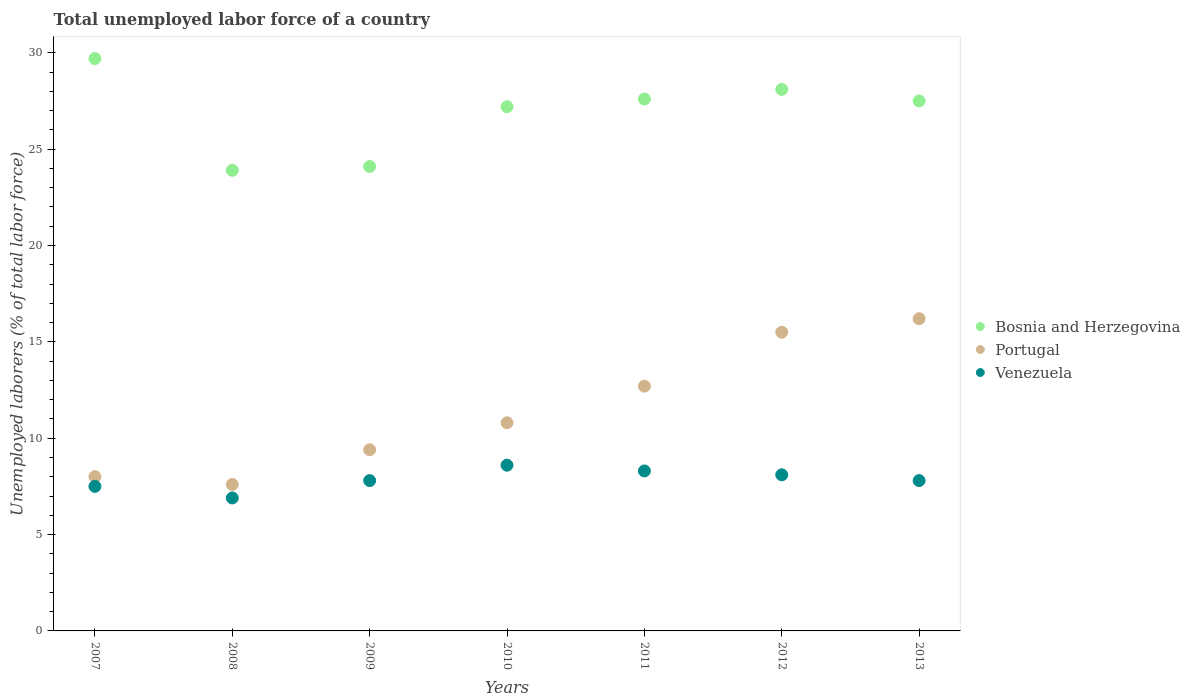Is the number of dotlines equal to the number of legend labels?
Keep it short and to the point. Yes. Across all years, what is the maximum total unemployed labor force in Bosnia and Herzegovina?
Your answer should be very brief. 29.7. Across all years, what is the minimum total unemployed labor force in Portugal?
Provide a short and direct response. 7.6. What is the total total unemployed labor force in Portugal in the graph?
Give a very brief answer. 80.2. What is the difference between the total unemployed labor force in Venezuela in 2007 and that in 2010?
Your answer should be compact. -1.1. What is the difference between the total unemployed labor force in Portugal in 2009 and the total unemployed labor force in Bosnia and Herzegovina in 2010?
Make the answer very short. -17.8. What is the average total unemployed labor force in Bosnia and Herzegovina per year?
Provide a short and direct response. 26.87. In the year 2011, what is the difference between the total unemployed labor force in Venezuela and total unemployed labor force in Portugal?
Ensure brevity in your answer.  -4.4. In how many years, is the total unemployed labor force in Venezuela greater than 6 %?
Make the answer very short. 7. What is the ratio of the total unemployed labor force in Bosnia and Herzegovina in 2007 to that in 2008?
Provide a succinct answer. 1.24. Is the total unemployed labor force in Venezuela in 2010 less than that in 2011?
Ensure brevity in your answer.  No. Is the difference between the total unemployed labor force in Venezuela in 2007 and 2011 greater than the difference between the total unemployed labor force in Portugal in 2007 and 2011?
Provide a succinct answer. Yes. What is the difference between the highest and the second highest total unemployed labor force in Bosnia and Herzegovina?
Provide a short and direct response. 1.6. What is the difference between the highest and the lowest total unemployed labor force in Venezuela?
Give a very brief answer. 1.7. Is the sum of the total unemployed labor force in Portugal in 2007 and 2009 greater than the maximum total unemployed labor force in Bosnia and Herzegovina across all years?
Give a very brief answer. No. Is the total unemployed labor force in Portugal strictly less than the total unemployed labor force in Venezuela over the years?
Make the answer very short. No. How many dotlines are there?
Keep it short and to the point. 3. How many years are there in the graph?
Your answer should be compact. 7. Are the values on the major ticks of Y-axis written in scientific E-notation?
Provide a succinct answer. No. Does the graph contain any zero values?
Keep it short and to the point. No. Does the graph contain grids?
Keep it short and to the point. No. How many legend labels are there?
Your answer should be very brief. 3. How are the legend labels stacked?
Ensure brevity in your answer.  Vertical. What is the title of the graph?
Keep it short and to the point. Total unemployed labor force of a country. What is the label or title of the Y-axis?
Ensure brevity in your answer.  Unemployed laborers (% of total labor force). What is the Unemployed laborers (% of total labor force) of Bosnia and Herzegovina in 2007?
Give a very brief answer. 29.7. What is the Unemployed laborers (% of total labor force) in Bosnia and Herzegovina in 2008?
Ensure brevity in your answer.  23.9. What is the Unemployed laborers (% of total labor force) of Portugal in 2008?
Your response must be concise. 7.6. What is the Unemployed laborers (% of total labor force) of Venezuela in 2008?
Make the answer very short. 6.9. What is the Unemployed laborers (% of total labor force) of Bosnia and Herzegovina in 2009?
Your answer should be very brief. 24.1. What is the Unemployed laborers (% of total labor force) of Portugal in 2009?
Offer a very short reply. 9.4. What is the Unemployed laborers (% of total labor force) of Venezuela in 2009?
Offer a terse response. 7.8. What is the Unemployed laborers (% of total labor force) in Bosnia and Herzegovina in 2010?
Ensure brevity in your answer.  27.2. What is the Unemployed laborers (% of total labor force) in Portugal in 2010?
Your answer should be compact. 10.8. What is the Unemployed laborers (% of total labor force) of Venezuela in 2010?
Your answer should be very brief. 8.6. What is the Unemployed laborers (% of total labor force) in Bosnia and Herzegovina in 2011?
Offer a very short reply. 27.6. What is the Unemployed laborers (% of total labor force) of Portugal in 2011?
Your answer should be compact. 12.7. What is the Unemployed laborers (% of total labor force) in Venezuela in 2011?
Ensure brevity in your answer.  8.3. What is the Unemployed laborers (% of total labor force) of Bosnia and Herzegovina in 2012?
Make the answer very short. 28.1. What is the Unemployed laborers (% of total labor force) in Portugal in 2012?
Provide a succinct answer. 15.5. What is the Unemployed laborers (% of total labor force) in Venezuela in 2012?
Provide a short and direct response. 8.1. What is the Unemployed laborers (% of total labor force) in Bosnia and Herzegovina in 2013?
Offer a terse response. 27.5. What is the Unemployed laborers (% of total labor force) of Portugal in 2013?
Offer a terse response. 16.2. What is the Unemployed laborers (% of total labor force) in Venezuela in 2013?
Offer a terse response. 7.8. Across all years, what is the maximum Unemployed laborers (% of total labor force) in Bosnia and Herzegovina?
Your answer should be compact. 29.7. Across all years, what is the maximum Unemployed laborers (% of total labor force) of Portugal?
Your answer should be very brief. 16.2. Across all years, what is the maximum Unemployed laborers (% of total labor force) in Venezuela?
Give a very brief answer. 8.6. Across all years, what is the minimum Unemployed laborers (% of total labor force) in Bosnia and Herzegovina?
Your answer should be compact. 23.9. Across all years, what is the minimum Unemployed laborers (% of total labor force) of Portugal?
Your answer should be compact. 7.6. Across all years, what is the minimum Unemployed laborers (% of total labor force) in Venezuela?
Your response must be concise. 6.9. What is the total Unemployed laborers (% of total labor force) of Bosnia and Herzegovina in the graph?
Keep it short and to the point. 188.1. What is the total Unemployed laborers (% of total labor force) in Portugal in the graph?
Give a very brief answer. 80.2. What is the difference between the Unemployed laborers (% of total labor force) in Portugal in 2007 and that in 2008?
Your response must be concise. 0.4. What is the difference between the Unemployed laborers (% of total labor force) of Venezuela in 2007 and that in 2008?
Your answer should be compact. 0.6. What is the difference between the Unemployed laborers (% of total labor force) in Bosnia and Herzegovina in 2007 and that in 2009?
Ensure brevity in your answer.  5.6. What is the difference between the Unemployed laborers (% of total labor force) in Venezuela in 2007 and that in 2009?
Keep it short and to the point. -0.3. What is the difference between the Unemployed laborers (% of total labor force) of Bosnia and Herzegovina in 2007 and that in 2010?
Offer a terse response. 2.5. What is the difference between the Unemployed laborers (% of total labor force) in Venezuela in 2007 and that in 2010?
Give a very brief answer. -1.1. What is the difference between the Unemployed laborers (% of total labor force) of Portugal in 2007 and that in 2011?
Keep it short and to the point. -4.7. What is the difference between the Unemployed laborers (% of total labor force) in Venezuela in 2007 and that in 2011?
Make the answer very short. -0.8. What is the difference between the Unemployed laborers (% of total labor force) of Bosnia and Herzegovina in 2007 and that in 2012?
Offer a very short reply. 1.6. What is the difference between the Unemployed laborers (% of total labor force) of Portugal in 2007 and that in 2012?
Your answer should be compact. -7.5. What is the difference between the Unemployed laborers (% of total labor force) in Bosnia and Herzegovina in 2007 and that in 2013?
Provide a succinct answer. 2.2. What is the difference between the Unemployed laborers (% of total labor force) of Bosnia and Herzegovina in 2008 and that in 2009?
Make the answer very short. -0.2. What is the difference between the Unemployed laborers (% of total labor force) of Venezuela in 2008 and that in 2009?
Provide a succinct answer. -0.9. What is the difference between the Unemployed laborers (% of total labor force) in Bosnia and Herzegovina in 2008 and that in 2010?
Your response must be concise. -3.3. What is the difference between the Unemployed laborers (% of total labor force) in Portugal in 2008 and that in 2010?
Give a very brief answer. -3.2. What is the difference between the Unemployed laborers (% of total labor force) in Venezuela in 2008 and that in 2010?
Offer a very short reply. -1.7. What is the difference between the Unemployed laborers (% of total labor force) in Bosnia and Herzegovina in 2008 and that in 2011?
Give a very brief answer. -3.7. What is the difference between the Unemployed laborers (% of total labor force) of Portugal in 2008 and that in 2011?
Provide a short and direct response. -5.1. What is the difference between the Unemployed laborers (% of total labor force) of Portugal in 2008 and that in 2012?
Provide a succinct answer. -7.9. What is the difference between the Unemployed laborers (% of total labor force) of Bosnia and Herzegovina in 2008 and that in 2013?
Make the answer very short. -3.6. What is the difference between the Unemployed laborers (% of total labor force) in Venezuela in 2008 and that in 2013?
Your answer should be very brief. -0.9. What is the difference between the Unemployed laborers (% of total labor force) in Venezuela in 2009 and that in 2010?
Keep it short and to the point. -0.8. What is the difference between the Unemployed laborers (% of total labor force) in Bosnia and Herzegovina in 2009 and that in 2011?
Keep it short and to the point. -3.5. What is the difference between the Unemployed laborers (% of total labor force) in Portugal in 2009 and that in 2011?
Your response must be concise. -3.3. What is the difference between the Unemployed laborers (% of total labor force) in Venezuela in 2009 and that in 2013?
Give a very brief answer. 0. What is the difference between the Unemployed laborers (% of total labor force) of Bosnia and Herzegovina in 2010 and that in 2011?
Your answer should be compact. -0.4. What is the difference between the Unemployed laborers (% of total labor force) in Bosnia and Herzegovina in 2010 and that in 2012?
Give a very brief answer. -0.9. What is the difference between the Unemployed laborers (% of total labor force) of Portugal in 2010 and that in 2012?
Your answer should be very brief. -4.7. What is the difference between the Unemployed laborers (% of total labor force) of Venezuela in 2010 and that in 2013?
Offer a very short reply. 0.8. What is the difference between the Unemployed laborers (% of total labor force) in Bosnia and Herzegovina in 2011 and that in 2013?
Give a very brief answer. 0.1. What is the difference between the Unemployed laborers (% of total labor force) of Portugal in 2011 and that in 2013?
Your answer should be compact. -3.5. What is the difference between the Unemployed laborers (% of total labor force) in Venezuela in 2011 and that in 2013?
Ensure brevity in your answer.  0.5. What is the difference between the Unemployed laborers (% of total labor force) in Portugal in 2012 and that in 2013?
Provide a short and direct response. -0.7. What is the difference between the Unemployed laborers (% of total labor force) of Venezuela in 2012 and that in 2013?
Make the answer very short. 0.3. What is the difference between the Unemployed laborers (% of total labor force) in Bosnia and Herzegovina in 2007 and the Unemployed laborers (% of total labor force) in Portugal in 2008?
Keep it short and to the point. 22.1. What is the difference between the Unemployed laborers (% of total labor force) of Bosnia and Herzegovina in 2007 and the Unemployed laborers (% of total labor force) of Venezuela in 2008?
Provide a short and direct response. 22.8. What is the difference between the Unemployed laborers (% of total labor force) in Portugal in 2007 and the Unemployed laborers (% of total labor force) in Venezuela in 2008?
Ensure brevity in your answer.  1.1. What is the difference between the Unemployed laborers (% of total labor force) of Bosnia and Herzegovina in 2007 and the Unemployed laborers (% of total labor force) of Portugal in 2009?
Your answer should be very brief. 20.3. What is the difference between the Unemployed laborers (% of total labor force) in Bosnia and Herzegovina in 2007 and the Unemployed laborers (% of total labor force) in Venezuela in 2009?
Keep it short and to the point. 21.9. What is the difference between the Unemployed laborers (% of total labor force) in Portugal in 2007 and the Unemployed laborers (% of total labor force) in Venezuela in 2009?
Keep it short and to the point. 0.2. What is the difference between the Unemployed laborers (% of total labor force) in Bosnia and Herzegovina in 2007 and the Unemployed laborers (% of total labor force) in Portugal in 2010?
Ensure brevity in your answer.  18.9. What is the difference between the Unemployed laborers (% of total labor force) in Bosnia and Herzegovina in 2007 and the Unemployed laborers (% of total labor force) in Venezuela in 2010?
Provide a succinct answer. 21.1. What is the difference between the Unemployed laborers (% of total labor force) in Portugal in 2007 and the Unemployed laborers (% of total labor force) in Venezuela in 2010?
Your answer should be compact. -0.6. What is the difference between the Unemployed laborers (% of total labor force) of Bosnia and Herzegovina in 2007 and the Unemployed laborers (% of total labor force) of Venezuela in 2011?
Keep it short and to the point. 21.4. What is the difference between the Unemployed laborers (% of total labor force) of Bosnia and Herzegovina in 2007 and the Unemployed laborers (% of total labor force) of Venezuela in 2012?
Your answer should be very brief. 21.6. What is the difference between the Unemployed laborers (% of total labor force) of Portugal in 2007 and the Unemployed laborers (% of total labor force) of Venezuela in 2012?
Offer a terse response. -0.1. What is the difference between the Unemployed laborers (% of total labor force) of Bosnia and Herzegovina in 2007 and the Unemployed laborers (% of total labor force) of Venezuela in 2013?
Your answer should be very brief. 21.9. What is the difference between the Unemployed laborers (% of total labor force) in Bosnia and Herzegovina in 2008 and the Unemployed laborers (% of total labor force) in Portugal in 2009?
Your answer should be compact. 14.5. What is the difference between the Unemployed laborers (% of total labor force) of Bosnia and Herzegovina in 2008 and the Unemployed laborers (% of total labor force) of Venezuela in 2009?
Your response must be concise. 16.1. What is the difference between the Unemployed laborers (% of total labor force) of Portugal in 2008 and the Unemployed laborers (% of total labor force) of Venezuela in 2009?
Keep it short and to the point. -0.2. What is the difference between the Unemployed laborers (% of total labor force) in Bosnia and Herzegovina in 2008 and the Unemployed laborers (% of total labor force) in Venezuela in 2011?
Make the answer very short. 15.6. What is the difference between the Unemployed laborers (% of total labor force) in Portugal in 2008 and the Unemployed laborers (% of total labor force) in Venezuela in 2011?
Your answer should be very brief. -0.7. What is the difference between the Unemployed laborers (% of total labor force) of Bosnia and Herzegovina in 2008 and the Unemployed laborers (% of total labor force) of Venezuela in 2012?
Your answer should be compact. 15.8. What is the difference between the Unemployed laborers (% of total labor force) in Portugal in 2008 and the Unemployed laborers (% of total labor force) in Venezuela in 2012?
Give a very brief answer. -0.5. What is the difference between the Unemployed laborers (% of total labor force) in Bosnia and Herzegovina in 2008 and the Unemployed laborers (% of total labor force) in Portugal in 2013?
Provide a short and direct response. 7.7. What is the difference between the Unemployed laborers (% of total labor force) of Bosnia and Herzegovina in 2009 and the Unemployed laborers (% of total labor force) of Portugal in 2010?
Provide a short and direct response. 13.3. What is the difference between the Unemployed laborers (% of total labor force) of Bosnia and Herzegovina in 2009 and the Unemployed laborers (% of total labor force) of Venezuela in 2010?
Give a very brief answer. 15.5. What is the difference between the Unemployed laborers (% of total labor force) in Bosnia and Herzegovina in 2009 and the Unemployed laborers (% of total labor force) in Portugal in 2011?
Ensure brevity in your answer.  11.4. What is the difference between the Unemployed laborers (% of total labor force) in Portugal in 2009 and the Unemployed laborers (% of total labor force) in Venezuela in 2011?
Your response must be concise. 1.1. What is the difference between the Unemployed laborers (% of total labor force) of Bosnia and Herzegovina in 2009 and the Unemployed laborers (% of total labor force) of Venezuela in 2012?
Give a very brief answer. 16. What is the difference between the Unemployed laborers (% of total labor force) of Bosnia and Herzegovina in 2009 and the Unemployed laborers (% of total labor force) of Portugal in 2013?
Your answer should be compact. 7.9. What is the difference between the Unemployed laborers (% of total labor force) in Bosnia and Herzegovina in 2009 and the Unemployed laborers (% of total labor force) in Venezuela in 2013?
Your answer should be compact. 16.3. What is the difference between the Unemployed laborers (% of total labor force) of Portugal in 2010 and the Unemployed laborers (% of total labor force) of Venezuela in 2012?
Your response must be concise. 2.7. What is the difference between the Unemployed laborers (% of total labor force) in Portugal in 2010 and the Unemployed laborers (% of total labor force) in Venezuela in 2013?
Provide a succinct answer. 3. What is the difference between the Unemployed laborers (% of total labor force) of Bosnia and Herzegovina in 2011 and the Unemployed laborers (% of total labor force) of Portugal in 2012?
Provide a succinct answer. 12.1. What is the difference between the Unemployed laborers (% of total labor force) of Bosnia and Herzegovina in 2011 and the Unemployed laborers (% of total labor force) of Venezuela in 2013?
Your answer should be very brief. 19.8. What is the difference between the Unemployed laborers (% of total labor force) of Portugal in 2011 and the Unemployed laborers (% of total labor force) of Venezuela in 2013?
Give a very brief answer. 4.9. What is the difference between the Unemployed laborers (% of total labor force) in Bosnia and Herzegovina in 2012 and the Unemployed laborers (% of total labor force) in Venezuela in 2013?
Your response must be concise. 20.3. What is the average Unemployed laborers (% of total labor force) of Bosnia and Herzegovina per year?
Ensure brevity in your answer.  26.87. What is the average Unemployed laborers (% of total labor force) of Portugal per year?
Give a very brief answer. 11.46. What is the average Unemployed laborers (% of total labor force) of Venezuela per year?
Give a very brief answer. 7.86. In the year 2007, what is the difference between the Unemployed laborers (% of total labor force) in Bosnia and Herzegovina and Unemployed laborers (% of total labor force) in Portugal?
Give a very brief answer. 21.7. In the year 2007, what is the difference between the Unemployed laborers (% of total labor force) in Bosnia and Herzegovina and Unemployed laborers (% of total labor force) in Venezuela?
Your response must be concise. 22.2. In the year 2007, what is the difference between the Unemployed laborers (% of total labor force) in Portugal and Unemployed laborers (% of total labor force) in Venezuela?
Give a very brief answer. 0.5. In the year 2008, what is the difference between the Unemployed laborers (% of total labor force) in Bosnia and Herzegovina and Unemployed laborers (% of total labor force) in Portugal?
Offer a terse response. 16.3. In the year 2008, what is the difference between the Unemployed laborers (% of total labor force) of Bosnia and Herzegovina and Unemployed laborers (% of total labor force) of Venezuela?
Offer a very short reply. 17. In the year 2008, what is the difference between the Unemployed laborers (% of total labor force) of Portugal and Unemployed laborers (% of total labor force) of Venezuela?
Give a very brief answer. 0.7. In the year 2009, what is the difference between the Unemployed laborers (% of total labor force) in Bosnia and Herzegovina and Unemployed laborers (% of total labor force) in Portugal?
Offer a very short reply. 14.7. In the year 2009, what is the difference between the Unemployed laborers (% of total labor force) of Bosnia and Herzegovina and Unemployed laborers (% of total labor force) of Venezuela?
Offer a terse response. 16.3. In the year 2010, what is the difference between the Unemployed laborers (% of total labor force) of Bosnia and Herzegovina and Unemployed laborers (% of total labor force) of Venezuela?
Your answer should be compact. 18.6. In the year 2010, what is the difference between the Unemployed laborers (% of total labor force) in Portugal and Unemployed laborers (% of total labor force) in Venezuela?
Make the answer very short. 2.2. In the year 2011, what is the difference between the Unemployed laborers (% of total labor force) of Bosnia and Herzegovina and Unemployed laborers (% of total labor force) of Portugal?
Your response must be concise. 14.9. In the year 2011, what is the difference between the Unemployed laborers (% of total labor force) in Bosnia and Herzegovina and Unemployed laborers (% of total labor force) in Venezuela?
Offer a very short reply. 19.3. In the year 2011, what is the difference between the Unemployed laborers (% of total labor force) of Portugal and Unemployed laborers (% of total labor force) of Venezuela?
Offer a terse response. 4.4. In the year 2012, what is the difference between the Unemployed laborers (% of total labor force) in Bosnia and Herzegovina and Unemployed laborers (% of total labor force) in Venezuela?
Give a very brief answer. 20. In the year 2013, what is the difference between the Unemployed laborers (% of total labor force) of Bosnia and Herzegovina and Unemployed laborers (% of total labor force) of Portugal?
Your answer should be very brief. 11.3. In the year 2013, what is the difference between the Unemployed laborers (% of total labor force) of Bosnia and Herzegovina and Unemployed laborers (% of total labor force) of Venezuela?
Offer a very short reply. 19.7. What is the ratio of the Unemployed laborers (% of total labor force) of Bosnia and Herzegovina in 2007 to that in 2008?
Ensure brevity in your answer.  1.24. What is the ratio of the Unemployed laborers (% of total labor force) of Portugal in 2007 to that in 2008?
Make the answer very short. 1.05. What is the ratio of the Unemployed laborers (% of total labor force) of Venezuela in 2007 to that in 2008?
Make the answer very short. 1.09. What is the ratio of the Unemployed laborers (% of total labor force) in Bosnia and Herzegovina in 2007 to that in 2009?
Your response must be concise. 1.23. What is the ratio of the Unemployed laborers (% of total labor force) in Portugal in 2007 to that in 2009?
Make the answer very short. 0.85. What is the ratio of the Unemployed laborers (% of total labor force) of Venezuela in 2007 to that in 2009?
Your response must be concise. 0.96. What is the ratio of the Unemployed laborers (% of total labor force) of Bosnia and Herzegovina in 2007 to that in 2010?
Ensure brevity in your answer.  1.09. What is the ratio of the Unemployed laborers (% of total labor force) in Portugal in 2007 to that in 2010?
Ensure brevity in your answer.  0.74. What is the ratio of the Unemployed laborers (% of total labor force) in Venezuela in 2007 to that in 2010?
Give a very brief answer. 0.87. What is the ratio of the Unemployed laborers (% of total labor force) in Bosnia and Herzegovina in 2007 to that in 2011?
Keep it short and to the point. 1.08. What is the ratio of the Unemployed laborers (% of total labor force) of Portugal in 2007 to that in 2011?
Ensure brevity in your answer.  0.63. What is the ratio of the Unemployed laborers (% of total labor force) of Venezuela in 2007 to that in 2011?
Keep it short and to the point. 0.9. What is the ratio of the Unemployed laborers (% of total labor force) in Bosnia and Herzegovina in 2007 to that in 2012?
Your answer should be very brief. 1.06. What is the ratio of the Unemployed laborers (% of total labor force) of Portugal in 2007 to that in 2012?
Keep it short and to the point. 0.52. What is the ratio of the Unemployed laborers (% of total labor force) of Venezuela in 2007 to that in 2012?
Make the answer very short. 0.93. What is the ratio of the Unemployed laborers (% of total labor force) of Bosnia and Herzegovina in 2007 to that in 2013?
Keep it short and to the point. 1.08. What is the ratio of the Unemployed laborers (% of total labor force) in Portugal in 2007 to that in 2013?
Keep it short and to the point. 0.49. What is the ratio of the Unemployed laborers (% of total labor force) in Venezuela in 2007 to that in 2013?
Your response must be concise. 0.96. What is the ratio of the Unemployed laborers (% of total labor force) of Portugal in 2008 to that in 2009?
Offer a very short reply. 0.81. What is the ratio of the Unemployed laborers (% of total labor force) of Venezuela in 2008 to that in 2009?
Provide a succinct answer. 0.88. What is the ratio of the Unemployed laborers (% of total labor force) of Bosnia and Herzegovina in 2008 to that in 2010?
Offer a terse response. 0.88. What is the ratio of the Unemployed laborers (% of total labor force) in Portugal in 2008 to that in 2010?
Provide a succinct answer. 0.7. What is the ratio of the Unemployed laborers (% of total labor force) of Venezuela in 2008 to that in 2010?
Make the answer very short. 0.8. What is the ratio of the Unemployed laborers (% of total labor force) of Bosnia and Herzegovina in 2008 to that in 2011?
Provide a succinct answer. 0.87. What is the ratio of the Unemployed laborers (% of total labor force) of Portugal in 2008 to that in 2011?
Ensure brevity in your answer.  0.6. What is the ratio of the Unemployed laborers (% of total labor force) in Venezuela in 2008 to that in 2011?
Make the answer very short. 0.83. What is the ratio of the Unemployed laborers (% of total labor force) of Bosnia and Herzegovina in 2008 to that in 2012?
Give a very brief answer. 0.85. What is the ratio of the Unemployed laborers (% of total labor force) of Portugal in 2008 to that in 2012?
Keep it short and to the point. 0.49. What is the ratio of the Unemployed laborers (% of total labor force) of Venezuela in 2008 to that in 2012?
Your answer should be compact. 0.85. What is the ratio of the Unemployed laborers (% of total labor force) in Bosnia and Herzegovina in 2008 to that in 2013?
Give a very brief answer. 0.87. What is the ratio of the Unemployed laborers (% of total labor force) in Portugal in 2008 to that in 2013?
Your response must be concise. 0.47. What is the ratio of the Unemployed laborers (% of total labor force) of Venezuela in 2008 to that in 2013?
Your answer should be very brief. 0.88. What is the ratio of the Unemployed laborers (% of total labor force) of Bosnia and Herzegovina in 2009 to that in 2010?
Keep it short and to the point. 0.89. What is the ratio of the Unemployed laborers (% of total labor force) of Portugal in 2009 to that in 2010?
Provide a short and direct response. 0.87. What is the ratio of the Unemployed laborers (% of total labor force) of Venezuela in 2009 to that in 2010?
Your response must be concise. 0.91. What is the ratio of the Unemployed laborers (% of total labor force) of Bosnia and Herzegovina in 2009 to that in 2011?
Give a very brief answer. 0.87. What is the ratio of the Unemployed laborers (% of total labor force) of Portugal in 2009 to that in 2011?
Your answer should be compact. 0.74. What is the ratio of the Unemployed laborers (% of total labor force) of Venezuela in 2009 to that in 2011?
Ensure brevity in your answer.  0.94. What is the ratio of the Unemployed laborers (% of total labor force) in Bosnia and Herzegovina in 2009 to that in 2012?
Provide a short and direct response. 0.86. What is the ratio of the Unemployed laborers (% of total labor force) in Portugal in 2009 to that in 2012?
Your response must be concise. 0.61. What is the ratio of the Unemployed laborers (% of total labor force) of Bosnia and Herzegovina in 2009 to that in 2013?
Your response must be concise. 0.88. What is the ratio of the Unemployed laborers (% of total labor force) in Portugal in 2009 to that in 2013?
Offer a terse response. 0.58. What is the ratio of the Unemployed laborers (% of total labor force) in Venezuela in 2009 to that in 2013?
Ensure brevity in your answer.  1. What is the ratio of the Unemployed laborers (% of total labor force) in Bosnia and Herzegovina in 2010 to that in 2011?
Make the answer very short. 0.99. What is the ratio of the Unemployed laborers (% of total labor force) of Portugal in 2010 to that in 2011?
Keep it short and to the point. 0.85. What is the ratio of the Unemployed laborers (% of total labor force) of Venezuela in 2010 to that in 2011?
Ensure brevity in your answer.  1.04. What is the ratio of the Unemployed laborers (% of total labor force) of Portugal in 2010 to that in 2012?
Provide a succinct answer. 0.7. What is the ratio of the Unemployed laborers (% of total labor force) in Venezuela in 2010 to that in 2012?
Your answer should be very brief. 1.06. What is the ratio of the Unemployed laborers (% of total labor force) of Portugal in 2010 to that in 2013?
Offer a terse response. 0.67. What is the ratio of the Unemployed laborers (% of total labor force) in Venezuela in 2010 to that in 2013?
Keep it short and to the point. 1.1. What is the ratio of the Unemployed laborers (% of total labor force) of Bosnia and Herzegovina in 2011 to that in 2012?
Give a very brief answer. 0.98. What is the ratio of the Unemployed laborers (% of total labor force) of Portugal in 2011 to that in 2012?
Offer a very short reply. 0.82. What is the ratio of the Unemployed laborers (% of total labor force) of Venezuela in 2011 to that in 2012?
Give a very brief answer. 1.02. What is the ratio of the Unemployed laborers (% of total labor force) of Bosnia and Herzegovina in 2011 to that in 2013?
Your answer should be very brief. 1. What is the ratio of the Unemployed laborers (% of total labor force) in Portugal in 2011 to that in 2013?
Provide a succinct answer. 0.78. What is the ratio of the Unemployed laborers (% of total labor force) in Venezuela in 2011 to that in 2013?
Offer a terse response. 1.06. What is the ratio of the Unemployed laborers (% of total labor force) of Bosnia and Herzegovina in 2012 to that in 2013?
Your answer should be very brief. 1.02. What is the ratio of the Unemployed laborers (% of total labor force) of Portugal in 2012 to that in 2013?
Give a very brief answer. 0.96. What is the difference between the highest and the second highest Unemployed laborers (% of total labor force) in Portugal?
Provide a succinct answer. 0.7. What is the difference between the highest and the lowest Unemployed laborers (% of total labor force) in Bosnia and Herzegovina?
Make the answer very short. 5.8. What is the difference between the highest and the lowest Unemployed laborers (% of total labor force) of Venezuela?
Provide a short and direct response. 1.7. 